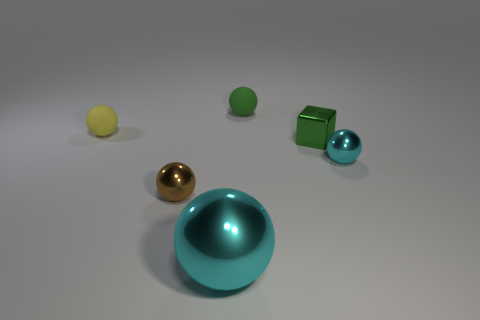Subtract 2 spheres. How many spheres are left? 3 Subtract all brown spheres. How many spheres are left? 4 Subtract all small cyan balls. How many balls are left? 4 Subtract all gray spheres. Subtract all gray cylinders. How many spheres are left? 5 Add 3 tiny blue rubber cubes. How many objects exist? 9 Subtract all cubes. How many objects are left? 5 Add 2 tiny cyan spheres. How many tiny cyan spheres are left? 3 Add 6 tiny cubes. How many tiny cubes exist? 7 Subtract 0 blue balls. How many objects are left? 6 Subtract all metallic things. Subtract all big cyan metal things. How many objects are left? 1 